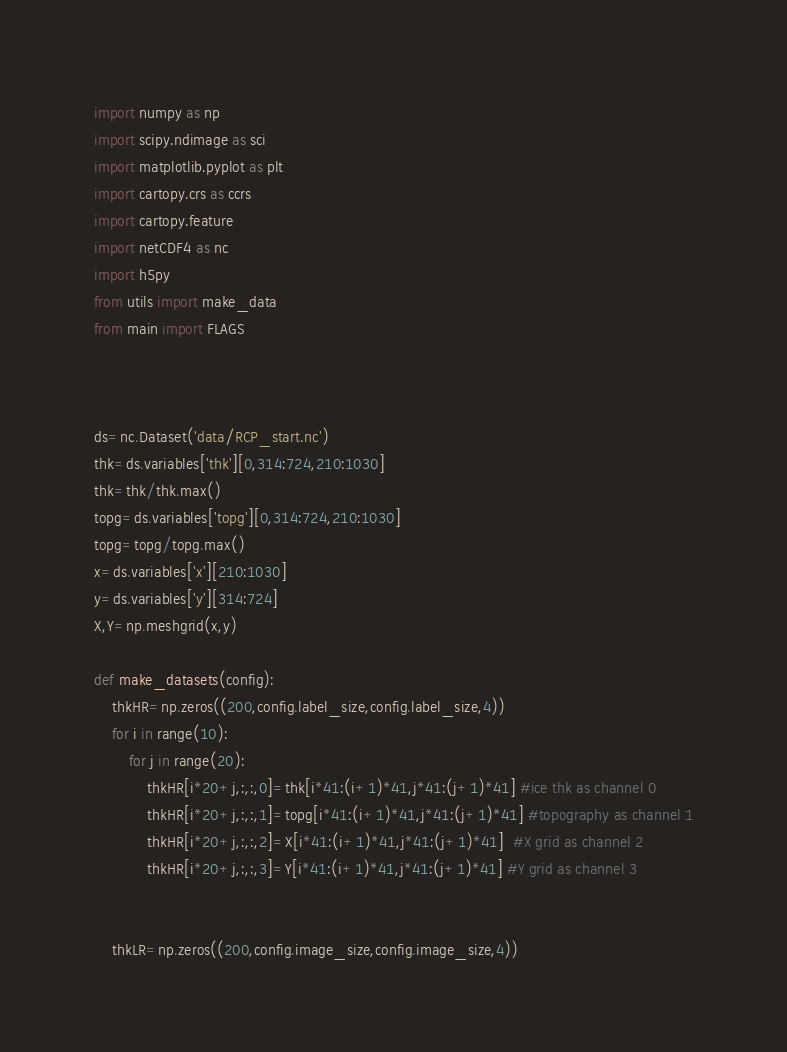Convert code to text. <code><loc_0><loc_0><loc_500><loc_500><_Python_>import numpy as np
import scipy.ndimage as sci
import matplotlib.pyplot as plt
import cartopy.crs as ccrs
import cartopy.feature
import netCDF4 as nc
import h5py
from utils import make_data
from main import FLAGS



ds=nc.Dataset('data/RCP_start.nc')
thk=ds.variables['thk'][0,314:724,210:1030]
thk=thk/thk.max()
topg=ds.variables['topg'][0,314:724,210:1030]
topg=topg/topg.max()
x=ds.variables['x'][210:1030]
y=ds.variables['y'][314:724]
X,Y=np.meshgrid(x,y)

def make_datasets(config):
    thkHR=np.zeros((200,config.label_size,config.label_size,4))
    for i in range(10):
        for j in range(20):
            thkHR[i*20+j,:,:,0]=thk[i*41:(i+1)*41,j*41:(j+1)*41] #ice thk as channel 0
            thkHR[i*20+j,:,:,1]=topg[i*41:(i+1)*41,j*41:(j+1)*41] #topography as channel 1
            thkHR[i*20+j,:,:,2]=X[i*41:(i+1)*41,j*41:(j+1)*41]  #X grid as channel 2
            thkHR[i*20+j,:,:,3]=Y[i*41:(i+1)*41,j*41:(j+1)*41] #Y grid as channel 3


    thkLR=np.zeros((200,config.image_size,config.image_size,4))</code> 